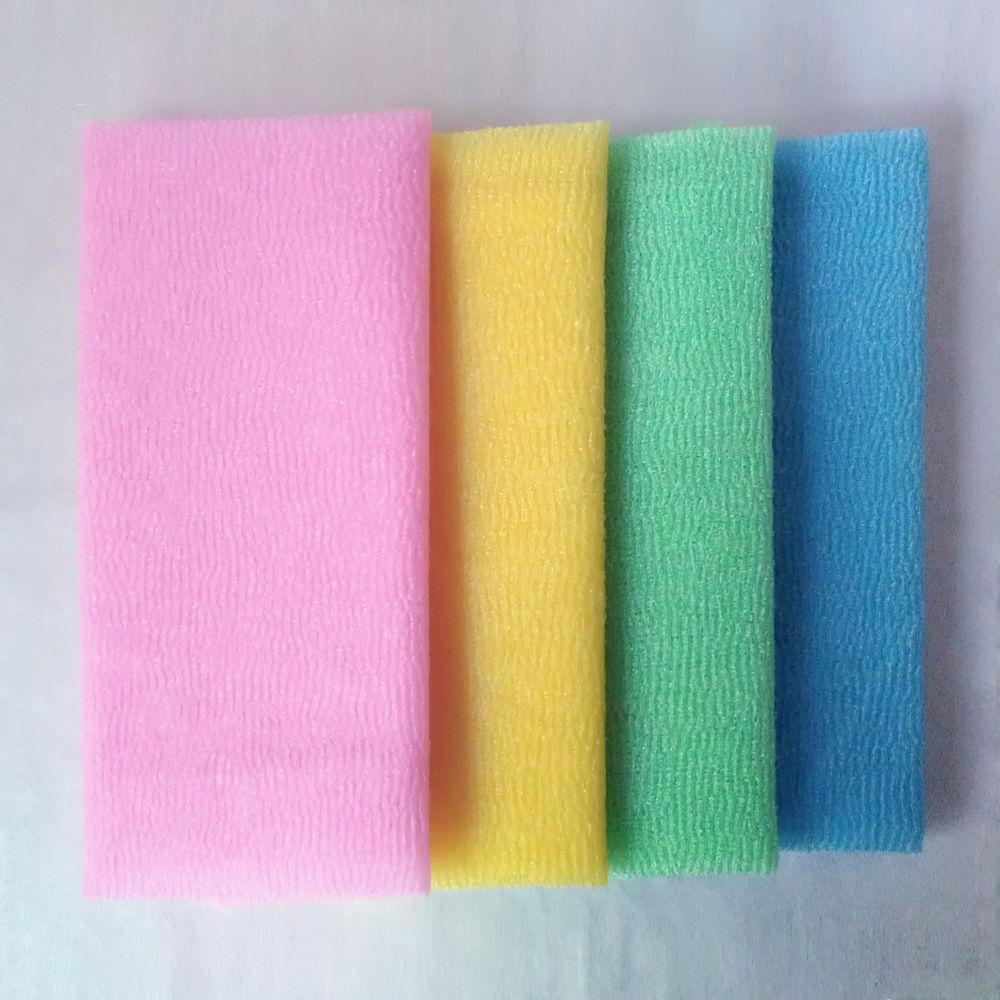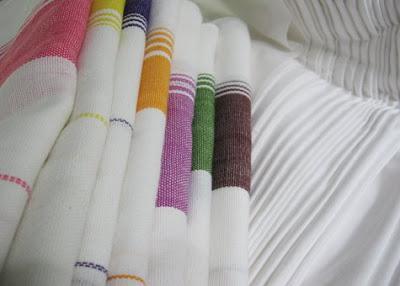The first image is the image on the left, the second image is the image on the right. Assess this claim about the two images: "One image shows flat, folded, overlapping cloths, and the other image shows the folded edges of white towels, each with differnt colored stripes.". Correct or not? Answer yes or no. Yes. The first image is the image on the left, the second image is the image on the right. Examine the images to the left and right. Is the description "In at least one image there are three hanging pieces of fabric in the bathroom." accurate? Answer yes or no. No. 